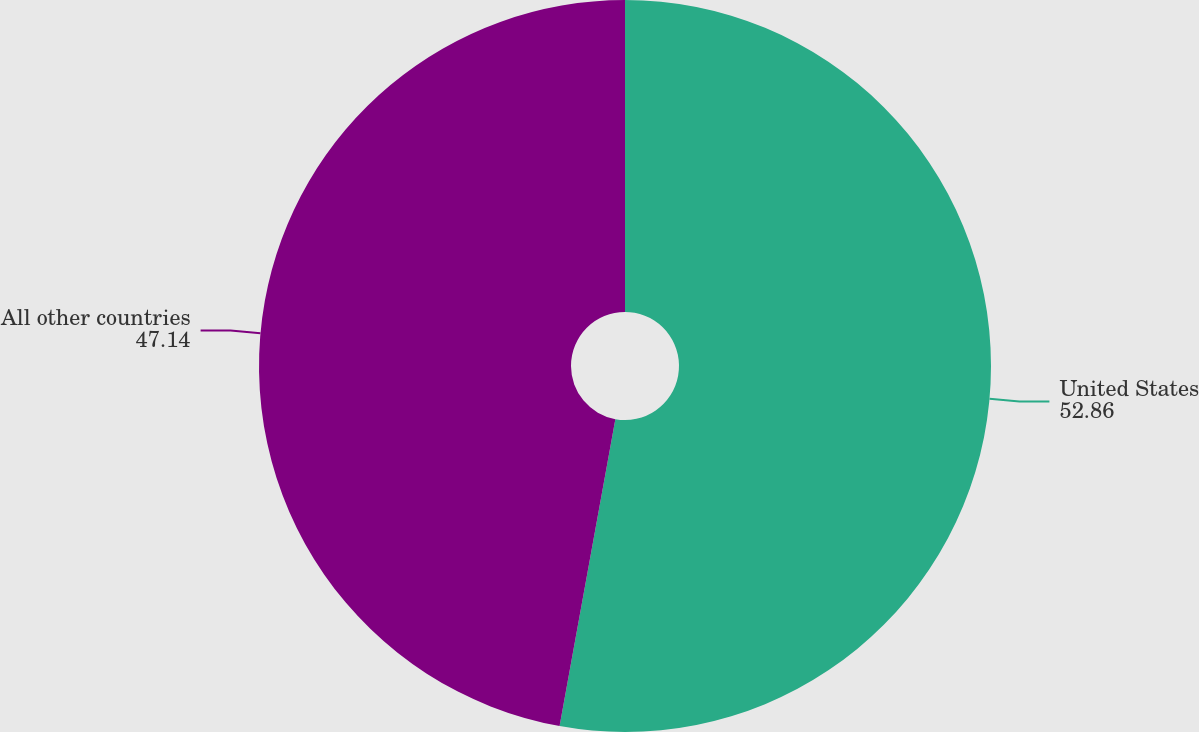Convert chart to OTSL. <chart><loc_0><loc_0><loc_500><loc_500><pie_chart><fcel>United States<fcel>All other countries<nl><fcel>52.86%<fcel>47.14%<nl></chart> 